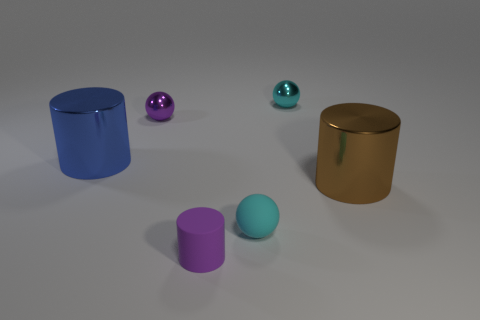Add 3 large gray metallic spheres. How many objects exist? 9 Subtract all tiny matte balls. Subtract all big cylinders. How many objects are left? 3 Add 1 tiny cyan shiny things. How many tiny cyan shiny things are left? 2 Add 3 big yellow balls. How many big yellow balls exist? 3 Subtract 0 brown cubes. How many objects are left? 6 